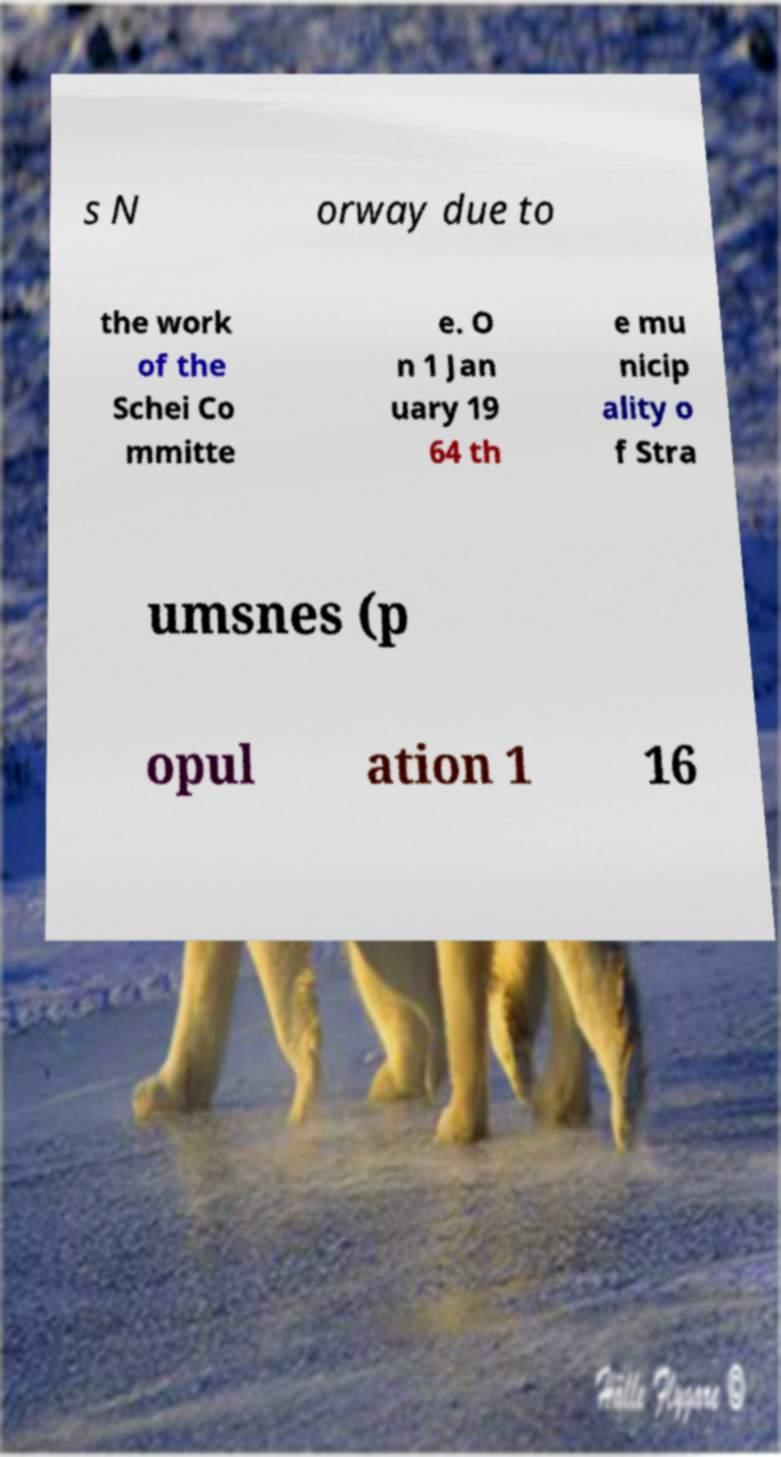Could you assist in decoding the text presented in this image and type it out clearly? s N orway due to the work of the Schei Co mmitte e. O n 1 Jan uary 19 64 th e mu nicip ality o f Stra umsnes (p opul ation 1 16 